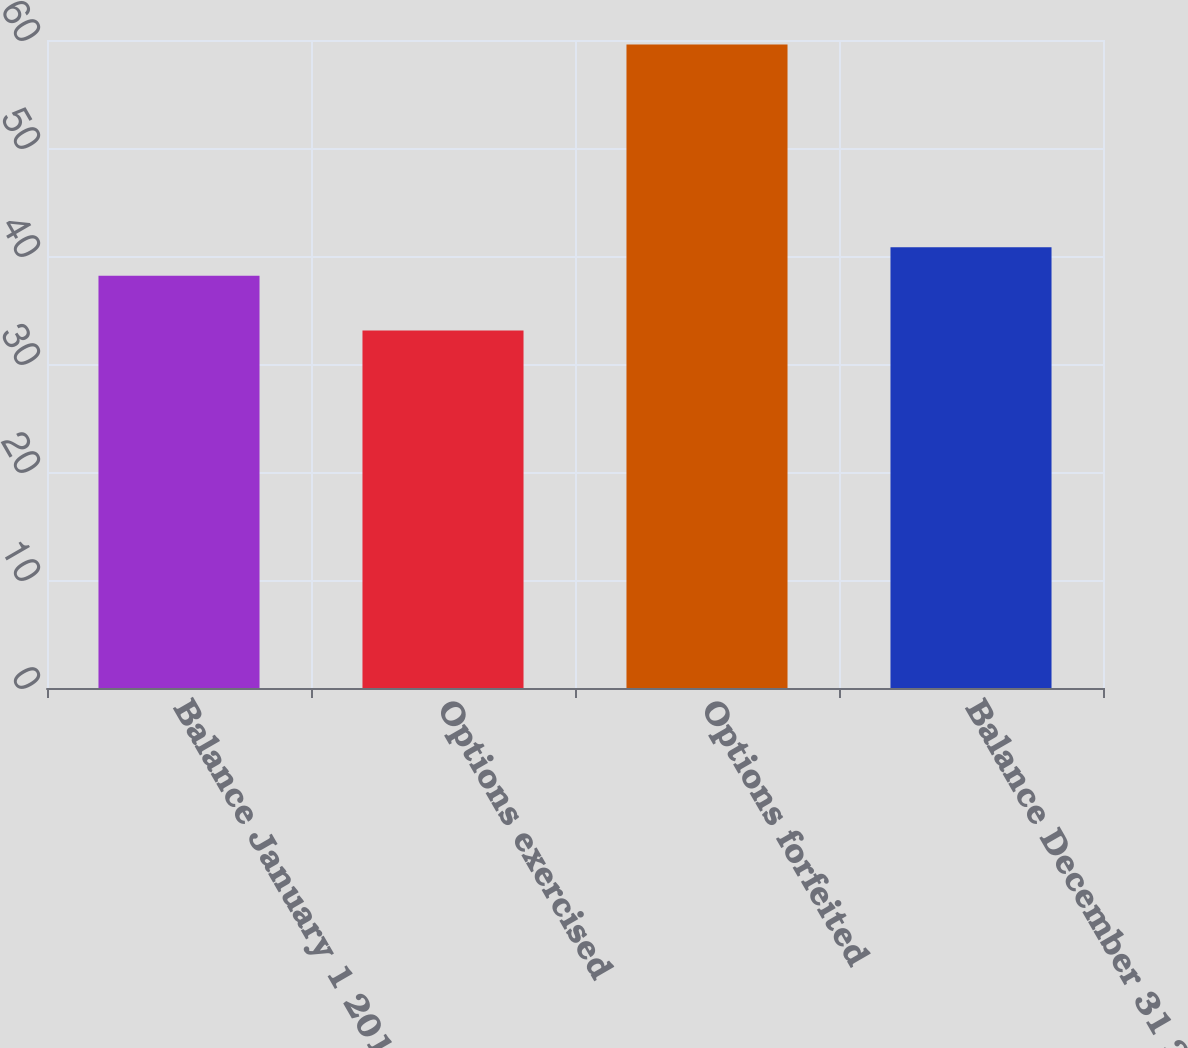Convert chart. <chart><loc_0><loc_0><loc_500><loc_500><bar_chart><fcel>Balance January 1 2012<fcel>Options exercised<fcel>Options forfeited<fcel>Balance December 31 2012<nl><fcel>38.17<fcel>33.11<fcel>59.58<fcel>40.82<nl></chart> 